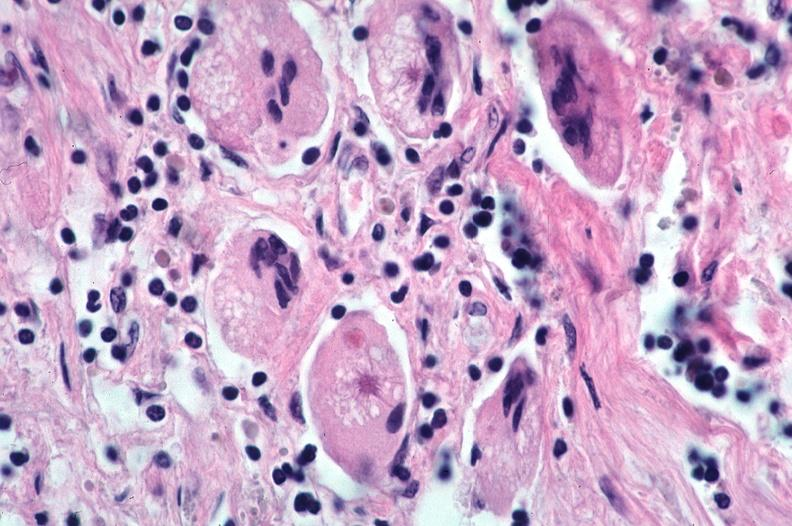does this image show lung, sarcoidosis, multinucleated giant cells with asteroid bodies?
Answer the question using a single word or phrase. Yes 